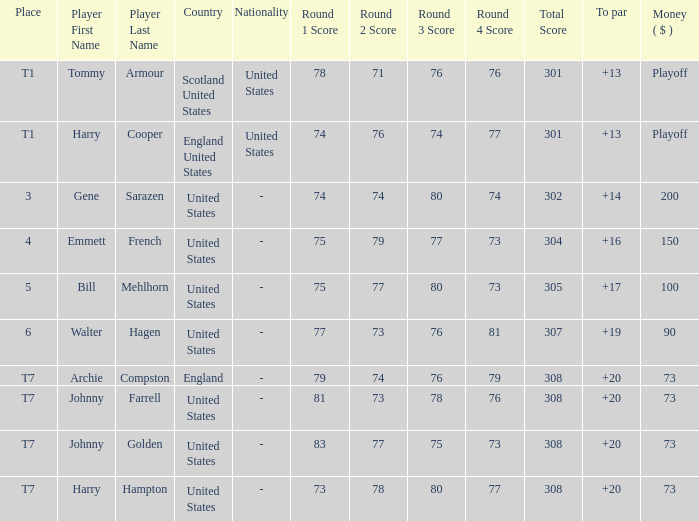What is the score for the United States when Harry Hampton is the player and the money is $73? 73-78-80-77=308. 